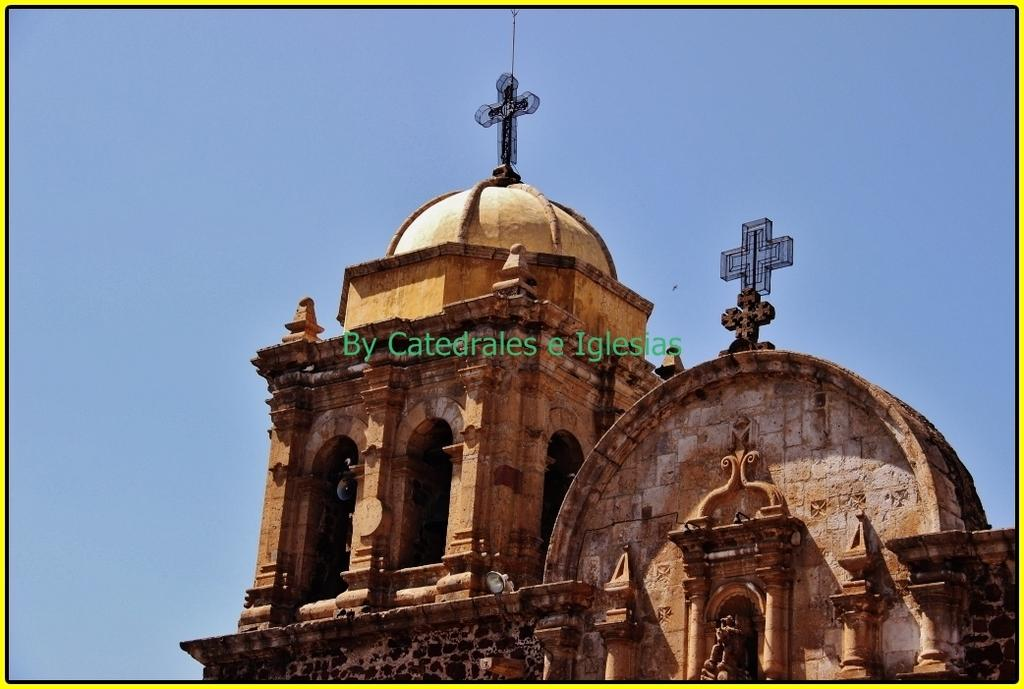What type of image is being described? The image is a photograph. What can be seen in the photograph besides the sky? There are buildings visible in the image. What is visible in the background of the photograph? The sky is visible in the image. How does the fog affect the visibility of the buildings in the image? There is no fog present in the image, so it does not affect the visibility of the buildings. 